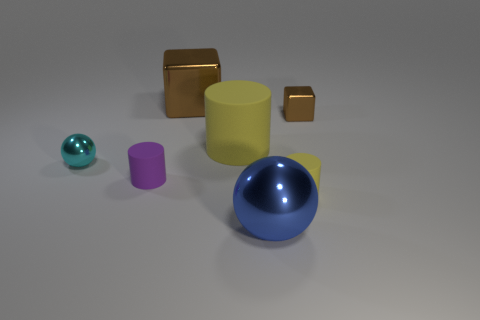There is a purple object that is the same shape as the big yellow matte object; what is its size?
Your answer should be compact. Small. What material is the other cube that is the same color as the tiny cube?
Ensure brevity in your answer.  Metal. There is a large block that is made of the same material as the cyan object; what color is it?
Your response must be concise. Brown. What is the color of the big matte thing?
Your answer should be compact. Yellow. Are the tiny brown cube and the sphere that is right of the purple object made of the same material?
Your response must be concise. Yes. How many yellow rubber things are behind the cyan metallic object and in front of the tiny cyan shiny ball?
Make the answer very short. 0. There is a brown metallic object that is the same size as the blue sphere; what shape is it?
Your answer should be compact. Cube. Are there any tiny cyan metal spheres that are behind the cylinder that is behind the tiny shiny thing that is to the left of the blue ball?
Your response must be concise. No. Is the color of the big cylinder the same as the tiny matte thing that is right of the big cylinder?
Offer a very short reply. Yes. What number of tiny shiny blocks are the same color as the big metallic cube?
Offer a very short reply. 1. 